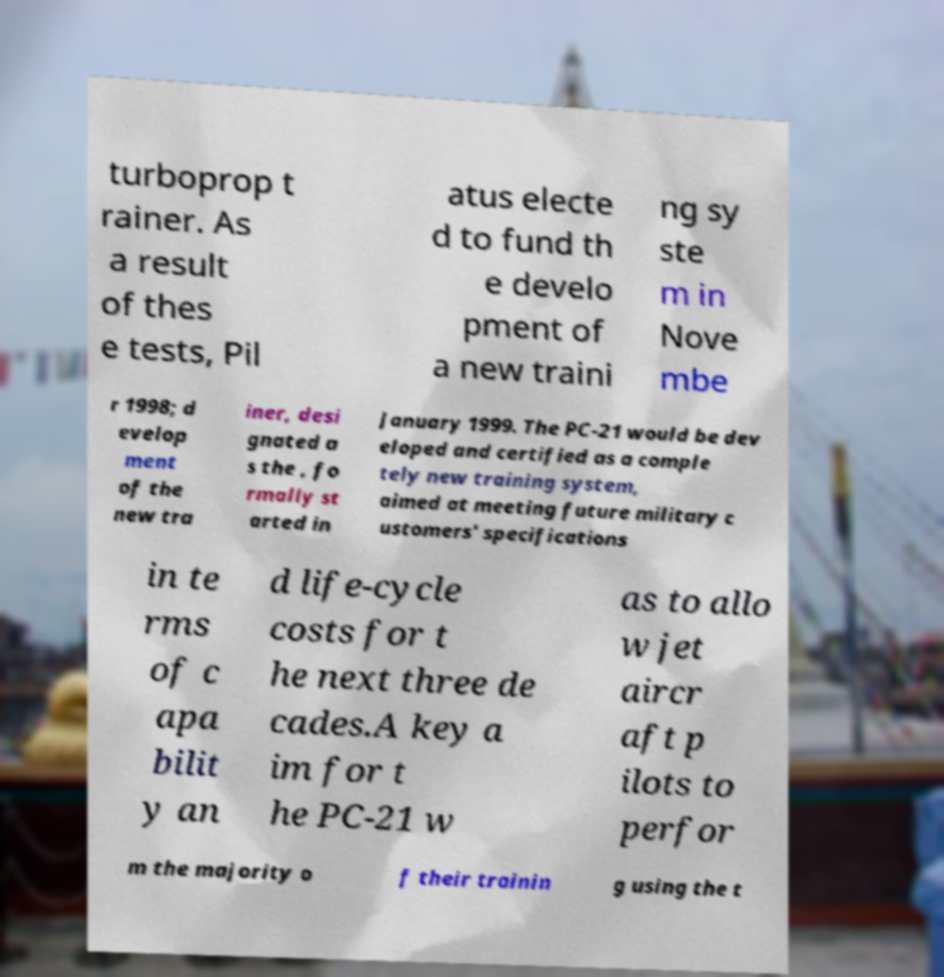There's text embedded in this image that I need extracted. Can you transcribe it verbatim? turboprop t rainer. As a result of thes e tests, Pil atus electe d to fund th e develo pment of a new traini ng sy ste m in Nove mbe r 1998; d evelop ment of the new tra iner, desi gnated a s the , fo rmally st arted in January 1999. The PC-21 would be dev eloped and certified as a comple tely new training system, aimed at meeting future military c ustomers' specifications in te rms of c apa bilit y an d life-cycle costs for t he next three de cades.A key a im for t he PC-21 w as to allo w jet aircr aft p ilots to perfor m the majority o f their trainin g using the t 